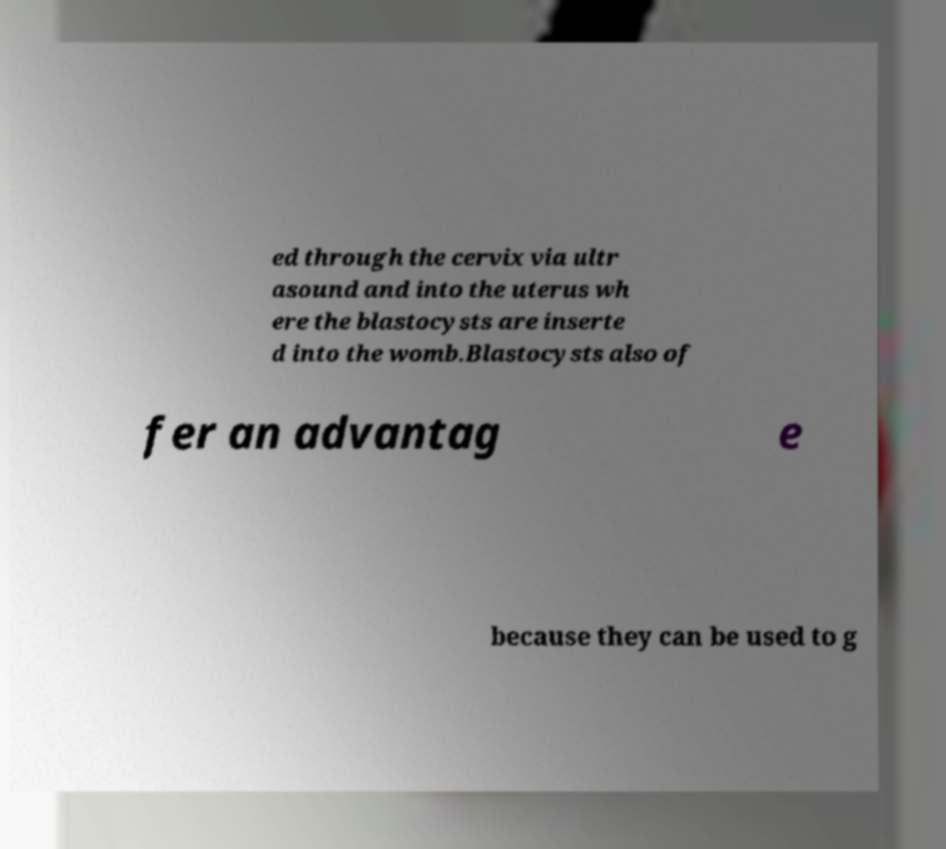Can you accurately transcribe the text from the provided image for me? ed through the cervix via ultr asound and into the uterus wh ere the blastocysts are inserte d into the womb.Blastocysts also of fer an advantag e because they can be used to g 